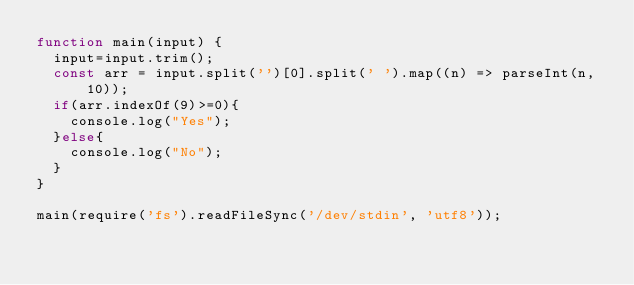Convert code to text. <code><loc_0><loc_0><loc_500><loc_500><_JavaScript_>function main(input) {
  input=input.trim();
  const arr = input.split('')[0].split(' ').map((n) => parseInt(n, 10));
  if(arr.indexOf(9)>=0){
    console.log("Yes");
  }else{
    console.log("No");
  }
}

main(require('fs').readFileSync('/dev/stdin', 'utf8'));

</code> 